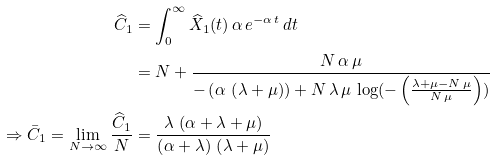Convert formula to latex. <formula><loc_0><loc_0><loc_500><loc_500>\widehat { C } _ { 1 } & = \int _ { 0 } ^ { \infty } \widehat { X } _ { 1 } ( t ) \, \alpha \, e ^ { - \alpha \, t } \, d t \\ & = N + \frac { N \, \alpha \, \mu } { - \left ( \alpha \, \left ( \lambda + \mu \right ) \right ) + N \, \lambda \, \mu \, \log ( - \left ( \frac { \lambda + \mu - N \, \mu } { N \, \mu } \right ) ) } \\ \Rightarrow \bar { C } _ { 1 } = \lim _ { N \rightarrow \infty } \frac { \widehat { C } _ { 1 } } { N } & = \frac { \lambda \, \left ( \alpha + \lambda + \mu \right ) } { \left ( \alpha + \lambda \right ) \, \left ( \lambda + \mu \right ) }</formula> 